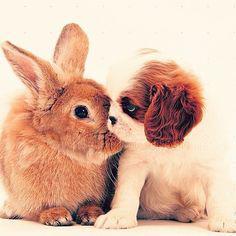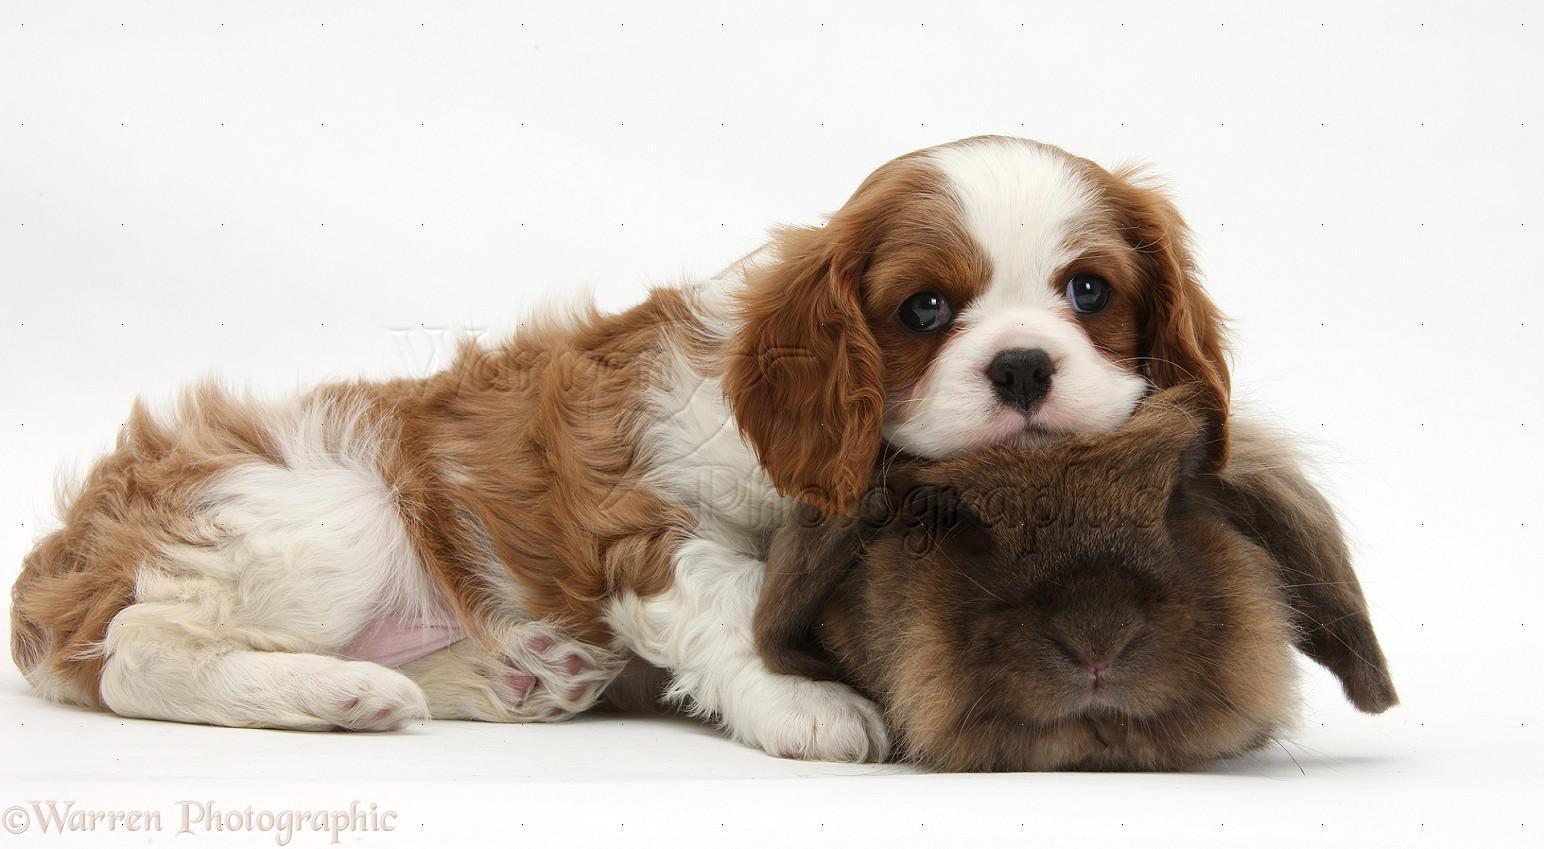The first image is the image on the left, the second image is the image on the right. Examine the images to the left and right. Is the description "In one of the images, a brown rabbit is in between two white and brown cocker spaniel puppies" accurate? Answer yes or no. No. The first image is the image on the left, the second image is the image on the right. For the images shown, is this caption "A rabbit is between two puppies in one image." true? Answer yes or no. No. 